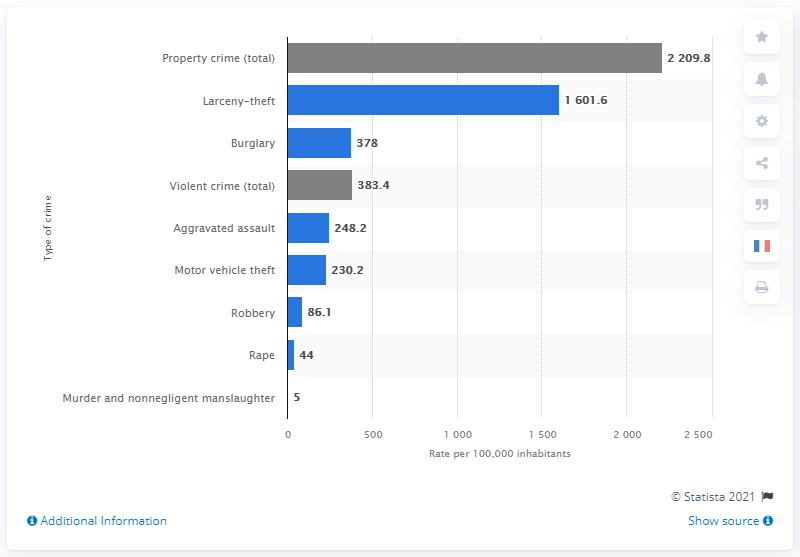Point out several critical features in this image. According to data from 2019, the top two crime rates in the United States were approximately 3811.4 crimes per 100,000 inhabitants. According to data from 2019, the crime rate of burglaries in the United States was approximately 378 incidents per 100,000 inhabitants. In 2019, the violent crime rate in the United States was 383.4 incidents per 100,000 people. 